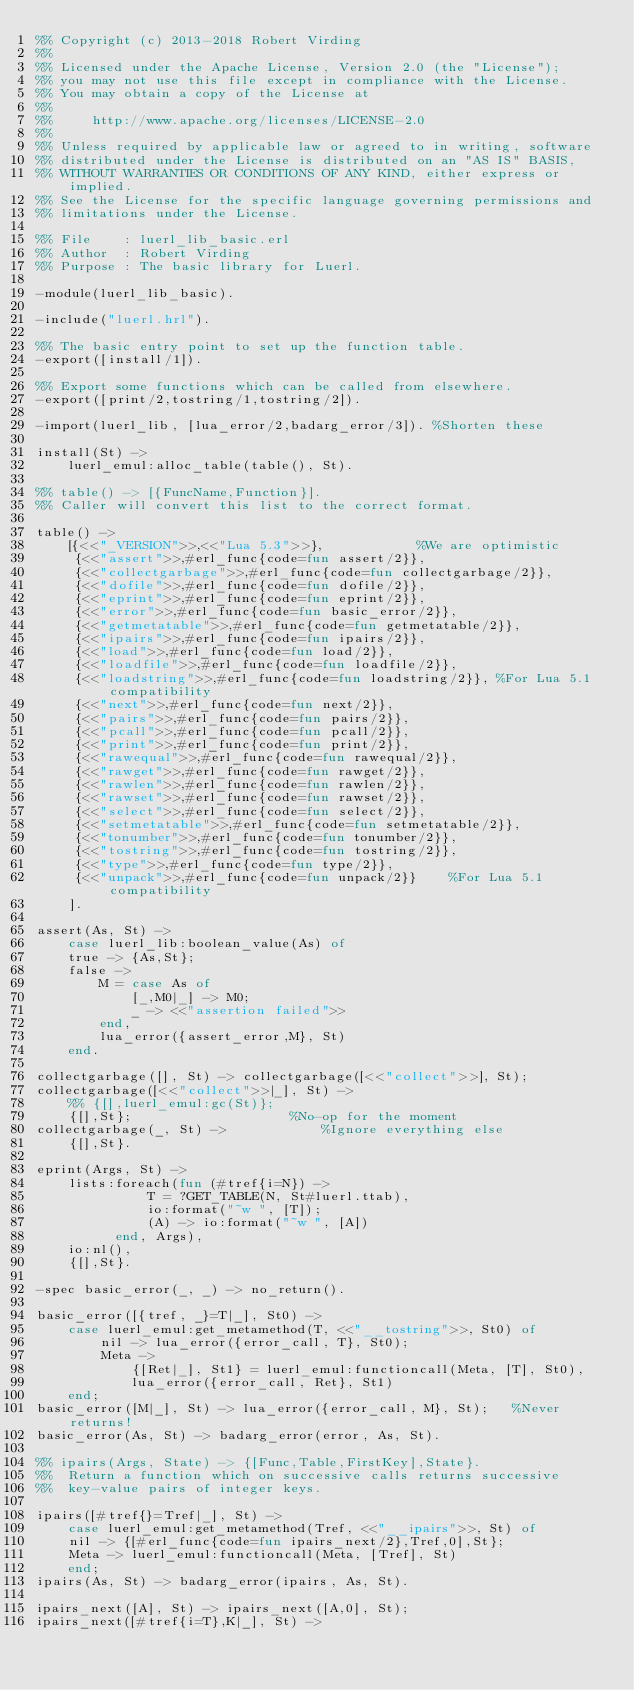Convert code to text. <code><loc_0><loc_0><loc_500><loc_500><_Erlang_>%% Copyright (c) 2013-2018 Robert Virding
%%
%% Licensed under the Apache License, Version 2.0 (the "License");
%% you may not use this file except in compliance with the License.
%% You may obtain a copy of the License at
%%
%%     http://www.apache.org/licenses/LICENSE-2.0
%%
%% Unless required by applicable law or agreed to in writing, software
%% distributed under the License is distributed on an "AS IS" BASIS,
%% WITHOUT WARRANTIES OR CONDITIONS OF ANY KIND, either express or implied.
%% See the License for the specific language governing permissions and
%% limitations under the License.

%% File    : luerl_lib_basic.erl
%% Author  : Robert Virding
%% Purpose : The basic library for Luerl.

-module(luerl_lib_basic).

-include("luerl.hrl").

%% The basic entry point to set up the function table.
-export([install/1]).

%% Export some functions which can be called from elsewhere.
-export([print/2,tostring/1,tostring/2]).

-import(luerl_lib, [lua_error/2,badarg_error/3]). %Shorten these

install(St) ->
    luerl_emul:alloc_table(table(), St).

%% table() -> [{FuncName,Function}].
%% Caller will convert this list to the correct format.

table() ->
    [{<<"_VERSION">>,<<"Lua 5.3">>},            %We are optimistic
     {<<"assert">>,#erl_func{code=fun assert/2}},
     {<<"collectgarbage">>,#erl_func{code=fun collectgarbage/2}},
     {<<"dofile">>,#erl_func{code=fun dofile/2}},
     {<<"eprint">>,#erl_func{code=fun eprint/2}},
     {<<"error">>,#erl_func{code=fun basic_error/2}},
     {<<"getmetatable">>,#erl_func{code=fun getmetatable/2}},
     {<<"ipairs">>,#erl_func{code=fun ipairs/2}},
     {<<"load">>,#erl_func{code=fun load/2}},
     {<<"loadfile">>,#erl_func{code=fun loadfile/2}},
     {<<"loadstring">>,#erl_func{code=fun loadstring/2}}, %For Lua 5.1 compatibility
     {<<"next">>,#erl_func{code=fun next/2}},
     {<<"pairs">>,#erl_func{code=fun pairs/2}},
     {<<"pcall">>,#erl_func{code=fun pcall/2}},
     {<<"print">>,#erl_func{code=fun print/2}},
     {<<"rawequal">>,#erl_func{code=fun rawequal/2}},
     {<<"rawget">>,#erl_func{code=fun rawget/2}},
     {<<"rawlen">>,#erl_func{code=fun rawlen/2}},
     {<<"rawset">>,#erl_func{code=fun rawset/2}},
     {<<"select">>,#erl_func{code=fun select/2}},
     {<<"setmetatable">>,#erl_func{code=fun setmetatable/2}},
     {<<"tonumber">>,#erl_func{code=fun tonumber/2}},
     {<<"tostring">>,#erl_func{code=fun tostring/2}},
     {<<"type">>,#erl_func{code=fun type/2}},
     {<<"unpack">>,#erl_func{code=fun unpack/2}}	%For Lua 5.1 compatibility
    ].

assert(As, St) ->
    case luerl_lib:boolean_value(As) of
	true -> {As,St};
	false ->
	    M = case As of
		    [_,M0|_] -> M0;
		    _ -> <<"assertion failed">>
		end,
	    lua_error({assert_error,M}, St)
    end.

collectgarbage([], St) -> collectgarbage([<<"collect">>], St);
collectgarbage([<<"collect">>|_], St) ->
    %% {[],luerl_emul:gc(St)};
    {[],St};					%No-op for the moment
collectgarbage(_, St) ->			%Ignore everything else
    {[],St}.

eprint(Args, St) ->
    lists:foreach(fun (#tref{i=N}) ->
			  T = ?GET_TABLE(N, St#luerl.ttab),
			  io:format("~w ", [T]);
		      (A) -> io:format("~w ", [A])
		  end, Args),
    io:nl(),
    {[],St}.

-spec basic_error(_, _) -> no_return().

basic_error([{tref, _}=T|_], St0) ->
    case luerl_emul:get_metamethod(T, <<"__tostring">>, St0) of
        nil -> lua_error({error_call, T}, St0);
        Meta ->
            {[Ret|_], St1} = luerl_emul:functioncall(Meta, [T], St0),
            lua_error({error_call, Ret}, St1)
    end;
basic_error([M|_], St) -> lua_error({error_call, M}, St);	%Never returns!
basic_error(As, St) -> badarg_error(error, As, St).

%% ipairs(Args, State) -> {[Func,Table,FirstKey],State}.
%%  Return a function which on successive calls returns successive
%%  key-value pairs of integer keys.

ipairs([#tref{}=Tref|_], St) ->
    case luerl_emul:get_metamethod(Tref, <<"__ipairs">>, St) of
	nil -> {[#erl_func{code=fun ipairs_next/2},Tref,0],St};
	Meta -> luerl_emul:functioncall(Meta, [Tref], St)
    end;
ipairs(As, St) -> badarg_error(ipairs, As, St).
    
ipairs_next([A], St) -> ipairs_next([A,0], St);
ipairs_next([#tref{i=T},K|_], St) -></code> 